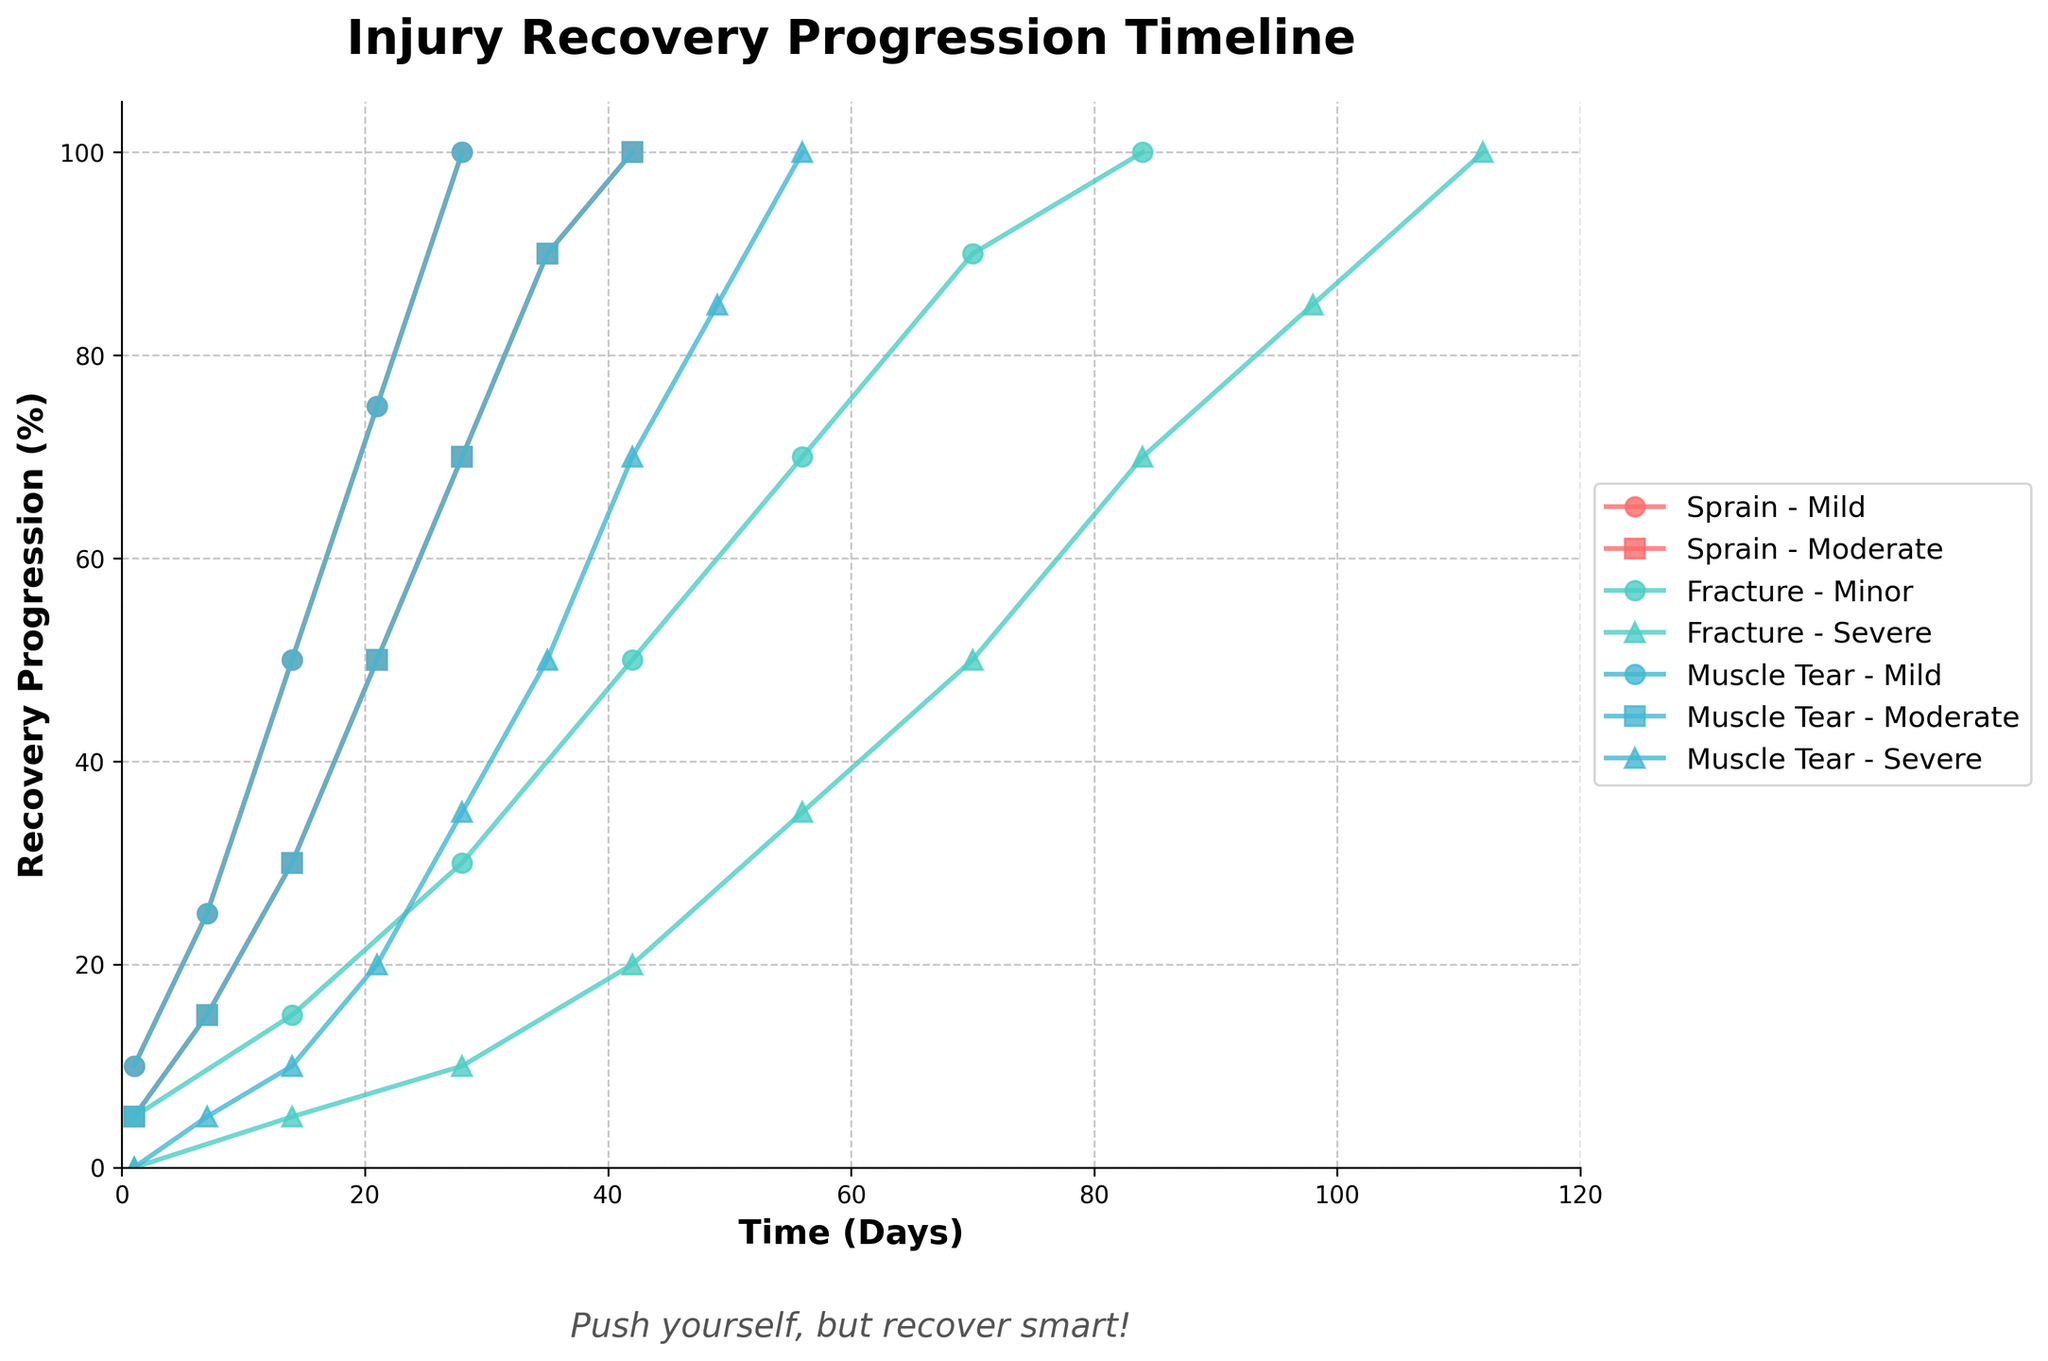What's the title of the figure? The title of the figure can be found at the top of the plot. It is 'Injury Recovery Progression Timeline'.
Answer: 'Injury Recovery Progression Timeline' What is the recovery progression percentage for a mild sprain after 14 days? To find this, look for the line representing a mild sprain (denoted by a marker and color) and find the point corresponding to 14 days on the x-axis. The y-axis value indicates the recovery progression percentage. For a mild sprain after 14 days, it is 50%.
Answer: 50% How does the progression of a moderate muscle tear compare between day 21 and day 28? First, locate the line representing a moderate muscle tear and identify the points at 21 and 28 days. At 21 days, the progression is 50%, and at 28 days, it is 70%. The recovery progression increases by 20 percentage points in this period.
Answer: It increased by 20 percentage points What is the maximum recovery progression reported for minor fractures? Locate the line and points representing minor fractures. The maximum y-axis value (recovery percentage) for minor fractures is 100%, observed at 84 days.
Answer: 100% Which injury has the quickest full recovery for mild severity? Compare the recovery points at 100% on the y-axis for mild severity injuries. A mild sprain reaches 100% at 28 days, a mild fracture reaches 100% at 84 days, and a mild muscle tear reaches 100% at 28 days. Both mild sprain and mild muscle tear recover fully the quickest in 28 days.
Answer: Sprain and Muscle Tear What is the relationship between the number of physiotherapy sessions and recovery progression for severe fractures over time? Examine the line representing severe fractures and observe the points corresponding to different time intervals. As time increases (shown on the x-axis), the number of physiotherapy sessions also increases, and the recovery progression (shown on the y-axis) steadily improves. This indicates a positive correlation between the number of physiotherapy sessions and recovery progression.
Answer: Positive correlation Compare the initial recovery progression (Day 1) between a mild muscle tear and a severe fracture. Locate the points for Day 1 on both the mild muscle tear and severe fracture lines. The mild muscle tear has an initial recovery progression of 10%, while the severe fracture has 0%. Therefore, the initial recovery progression for a mild muscle tear is higher than that of a severe fracture.
Answer: Mild muscle tear higher Which injury type shows the slowest recovery progression for severe cases until the first 28 days? Observe the lines for severe cases of sprains, fractures, and muscle tears. The severe fracture initially reports 0% recovery at Day 1 and progresses slowly to only 35% by Day 28. Both severe muscle tears and severe sprains have higher recovery progressions by Day 28 (50% for muscle tear and 35% for fracture). Thus, severe fractures show the slowest recovery.
Answer: Severe fracture How many physiotherapy sessions are needed to achieve a 100% recovery progression for a severe muscle tear and when is this achieved? Track the severe muscle tear line and find the point where it reaches 100% recovery progression and the corresponding number of physiotherapy sessions. This point is found at Day 56 with 16 physiotherapy sessions.
Answer: 16 sessions at 56 days What can be inferred about the recovery progression trend for moderate sprains over a 42-day period? Follow the line representing moderate sprains. Over the 42-day period, the recovery progression increases steadily, with values at various checkpoints (7 days: 15%, 14 days: 30%, 21 days: 50%, 28 days: 70%, 35 days: 90%, and 42 days: 100%). The trend shows a consistent recovery progression.
Answer: Steady increase 